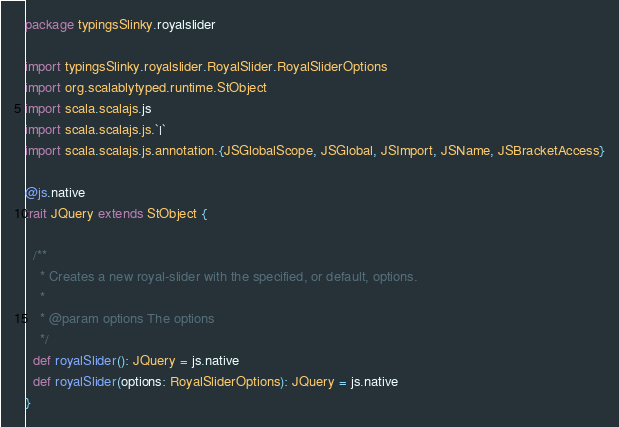Convert code to text. <code><loc_0><loc_0><loc_500><loc_500><_Scala_>package typingsSlinky.royalslider

import typingsSlinky.royalslider.RoyalSlider.RoyalSliderOptions
import org.scalablytyped.runtime.StObject
import scala.scalajs.js
import scala.scalajs.js.`|`
import scala.scalajs.js.annotation.{JSGlobalScope, JSGlobal, JSImport, JSName, JSBracketAccess}

@js.native
trait JQuery extends StObject {
  
  /**
    * Creates a new royal-slider with the specified, or default, options.
    *
    * @param options The options
    */
  def royalSlider(): JQuery = js.native
  def royalSlider(options: RoyalSliderOptions): JQuery = js.native
}
</code> 